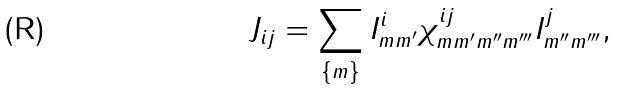Convert formula to latex. <formula><loc_0><loc_0><loc_500><loc_500>J _ { i j } = \sum _ { \{ m \} } I _ { m m ^ { \prime } } ^ { i } \chi _ { m m ^ { \prime } m ^ { \prime \prime } m ^ { \prime \prime \prime } } ^ { i j } I _ { m ^ { \prime \prime } m ^ { \prime \prime \prime } } ^ { j } ,</formula> 